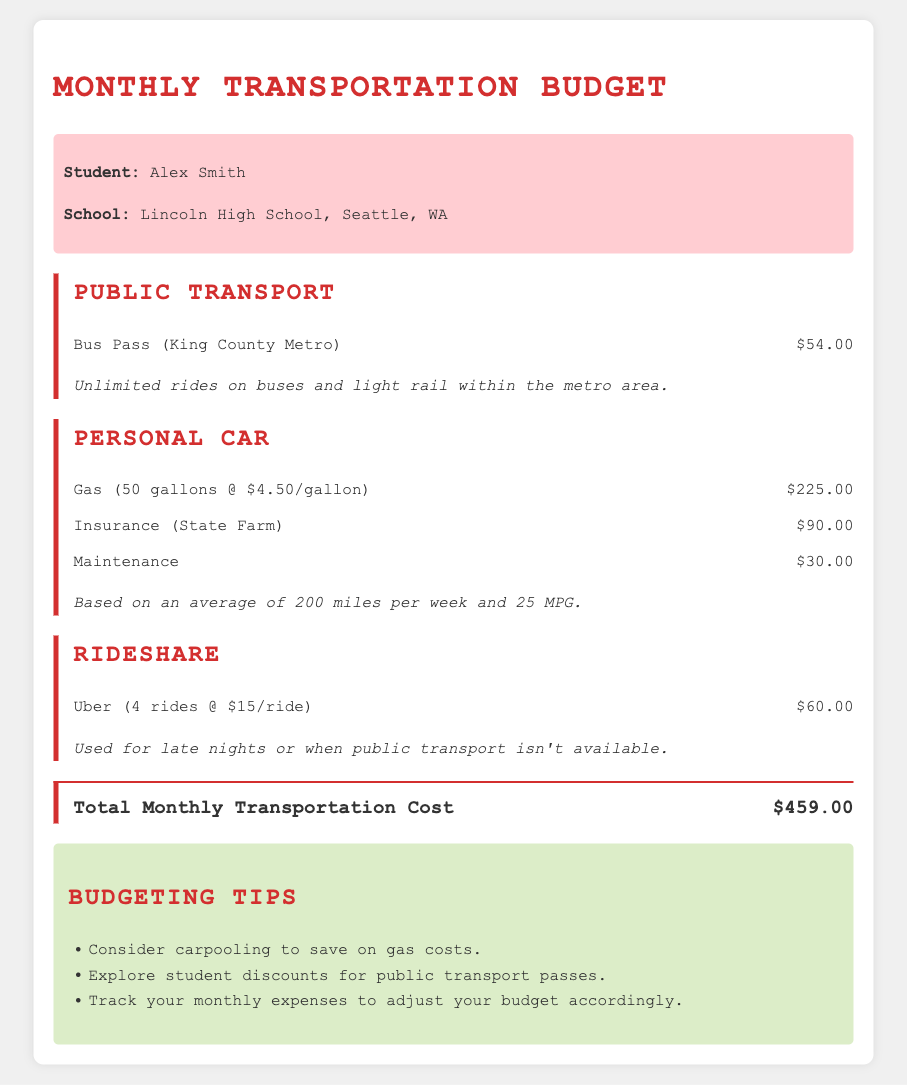What is the student’s name? The student's name is mentioned in the student info section.
Answer: Alex Smith How much does a bus pass cost? The cost of the bus pass is specified under the public transport section.
Answer: $54.00 What is the total monthly transportation cost? The total monthly transportation cost is listed at the bottom of the budget section.
Answer: $459.00 How much is the gas expense based on gallons and price per gallon? The gas expense is detailed under the personal car section, showing the total from the calculation provided.
Answer: $225.00 What insurance company is listed in the budget? The insurance company mentioned in the personal car section is State Farm.
Answer: State Farm How many rideshare rides are budgeted for Uber? The number of rides specified in the rideshare section is explicitly mentioned.
Answer: 4 rides What is a budgeting tip related to public transport? One of the tips in the budgeting section suggests finding discounts specifically for public transport.
Answer: Explore student discounts for public transport passes What is the maintenance cost for the personal car? The maintenance cost is provided in the personal car section of the document.
Answer: $30.00 